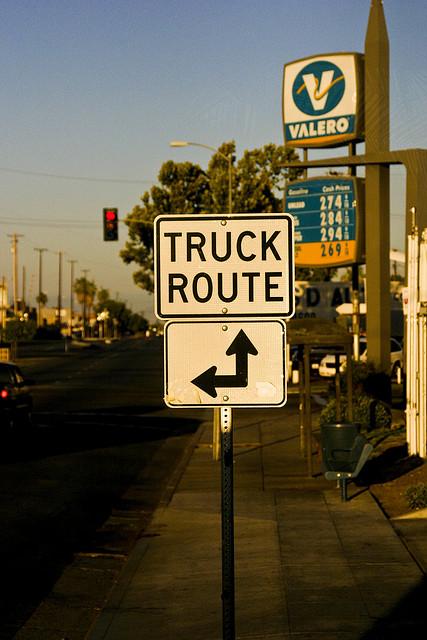What is the price for diesel?
Give a very brief answer. 2.69. What is the sign saying with the arrow?
Be succinct. Truck route. What is on green object on the white sign?
Give a very brief answer. V. What time of day is it?
Short answer required. Afternoon. Is the arrow point to the left or right?
Short answer required. Left. Are commercial vehicles allowed on this street?
Give a very brief answer. Yes. What kind of sign is this?
Short answer required. Truck route sign. Are these good gas prices for current times?
Give a very brief answer. Yes. What does the sign say?
Concise answer only. Truck route. What is the name of the gas station?
Short answer required. Valero. How many people in the photo?
Short answer required. 0. 